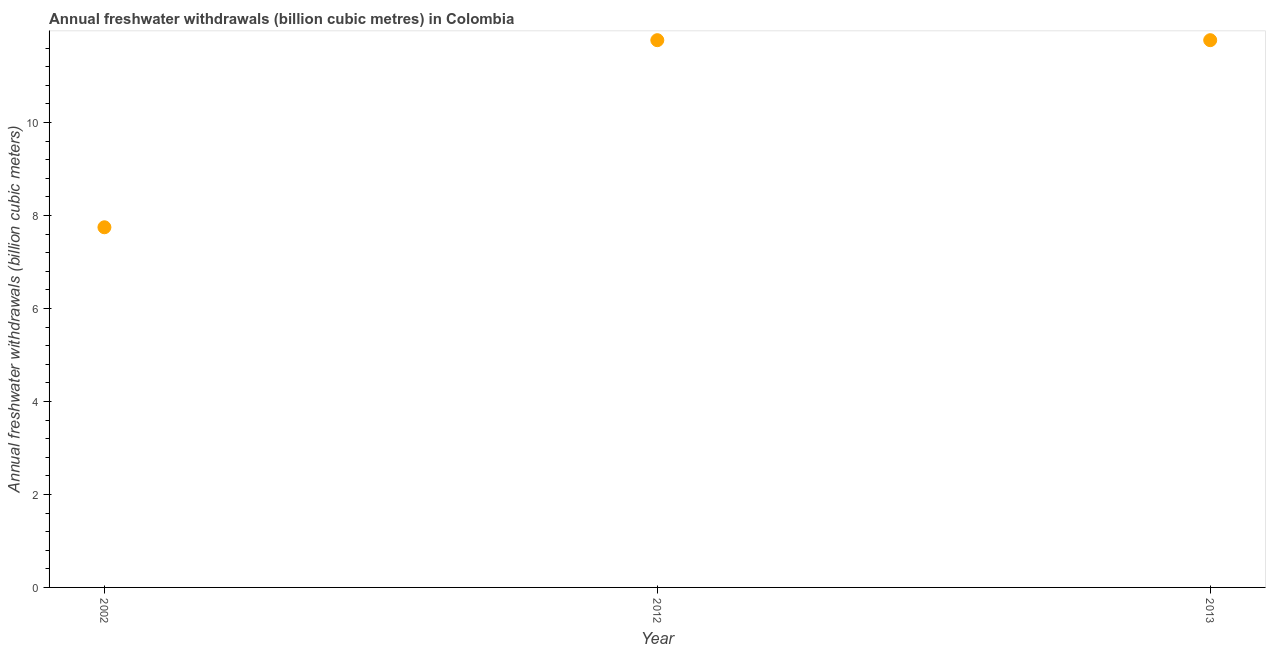What is the annual freshwater withdrawals in 2013?
Offer a terse response. 11.77. Across all years, what is the maximum annual freshwater withdrawals?
Make the answer very short. 11.77. Across all years, what is the minimum annual freshwater withdrawals?
Provide a succinct answer. 7.75. In which year was the annual freshwater withdrawals maximum?
Your answer should be compact. 2012. In which year was the annual freshwater withdrawals minimum?
Ensure brevity in your answer.  2002. What is the sum of the annual freshwater withdrawals?
Provide a short and direct response. 31.29. What is the difference between the annual freshwater withdrawals in 2012 and 2013?
Ensure brevity in your answer.  0. What is the average annual freshwater withdrawals per year?
Provide a succinct answer. 10.43. What is the median annual freshwater withdrawals?
Your answer should be compact. 11.77. In how many years, is the annual freshwater withdrawals greater than 1.2000000000000002 billion cubic meters?
Make the answer very short. 3. Do a majority of the years between 2002 and 2012 (inclusive) have annual freshwater withdrawals greater than 8.4 billion cubic meters?
Keep it short and to the point. No. What is the ratio of the annual freshwater withdrawals in 2012 to that in 2013?
Keep it short and to the point. 1. Is the difference between the annual freshwater withdrawals in 2012 and 2013 greater than the difference between any two years?
Your answer should be compact. No. What is the difference between the highest and the lowest annual freshwater withdrawals?
Keep it short and to the point. 4.02. How many dotlines are there?
Provide a succinct answer. 1. Are the values on the major ticks of Y-axis written in scientific E-notation?
Ensure brevity in your answer.  No. Does the graph contain any zero values?
Ensure brevity in your answer.  No. Does the graph contain grids?
Offer a very short reply. No. What is the title of the graph?
Your answer should be compact. Annual freshwater withdrawals (billion cubic metres) in Colombia. What is the label or title of the Y-axis?
Keep it short and to the point. Annual freshwater withdrawals (billion cubic meters). What is the Annual freshwater withdrawals (billion cubic meters) in 2002?
Provide a short and direct response. 7.75. What is the Annual freshwater withdrawals (billion cubic meters) in 2012?
Your answer should be very brief. 11.77. What is the Annual freshwater withdrawals (billion cubic meters) in 2013?
Make the answer very short. 11.77. What is the difference between the Annual freshwater withdrawals (billion cubic meters) in 2002 and 2012?
Provide a short and direct response. -4.02. What is the difference between the Annual freshwater withdrawals (billion cubic meters) in 2002 and 2013?
Your response must be concise. -4.02. What is the difference between the Annual freshwater withdrawals (billion cubic meters) in 2012 and 2013?
Offer a very short reply. 0. What is the ratio of the Annual freshwater withdrawals (billion cubic meters) in 2002 to that in 2012?
Ensure brevity in your answer.  0.66. What is the ratio of the Annual freshwater withdrawals (billion cubic meters) in 2002 to that in 2013?
Provide a short and direct response. 0.66. 